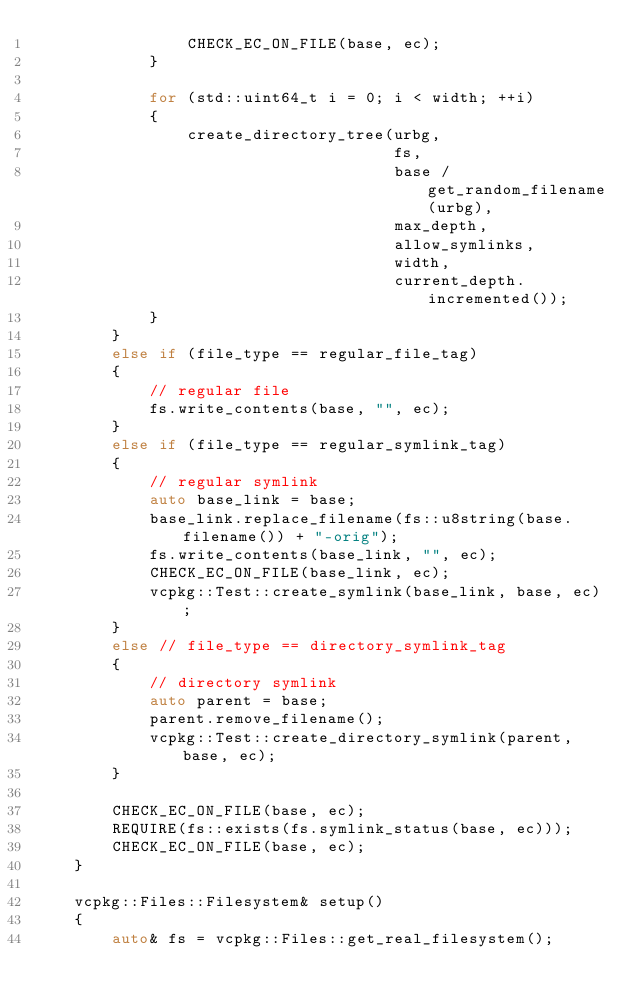Convert code to text. <code><loc_0><loc_0><loc_500><loc_500><_C++_>                CHECK_EC_ON_FILE(base, ec);
            }

            for (std::uint64_t i = 0; i < width; ++i)
            {
                create_directory_tree(urbg,
                                      fs,
                                      base / get_random_filename(urbg),
                                      max_depth,
                                      allow_symlinks,
                                      width,
                                      current_depth.incremented());
            }
        }
        else if (file_type == regular_file_tag)
        {
            // regular file
            fs.write_contents(base, "", ec);
        }
        else if (file_type == regular_symlink_tag)
        {
            // regular symlink
            auto base_link = base;
            base_link.replace_filename(fs::u8string(base.filename()) + "-orig");
            fs.write_contents(base_link, "", ec);
            CHECK_EC_ON_FILE(base_link, ec);
            vcpkg::Test::create_symlink(base_link, base, ec);
        }
        else // file_type == directory_symlink_tag
        {
            // directory symlink
            auto parent = base;
            parent.remove_filename();
            vcpkg::Test::create_directory_symlink(parent, base, ec);
        }

        CHECK_EC_ON_FILE(base, ec);
        REQUIRE(fs::exists(fs.symlink_status(base, ec)));
        CHECK_EC_ON_FILE(base, ec);
    }

    vcpkg::Files::Filesystem& setup()
    {
        auto& fs = vcpkg::Files::get_real_filesystem();
</code> 